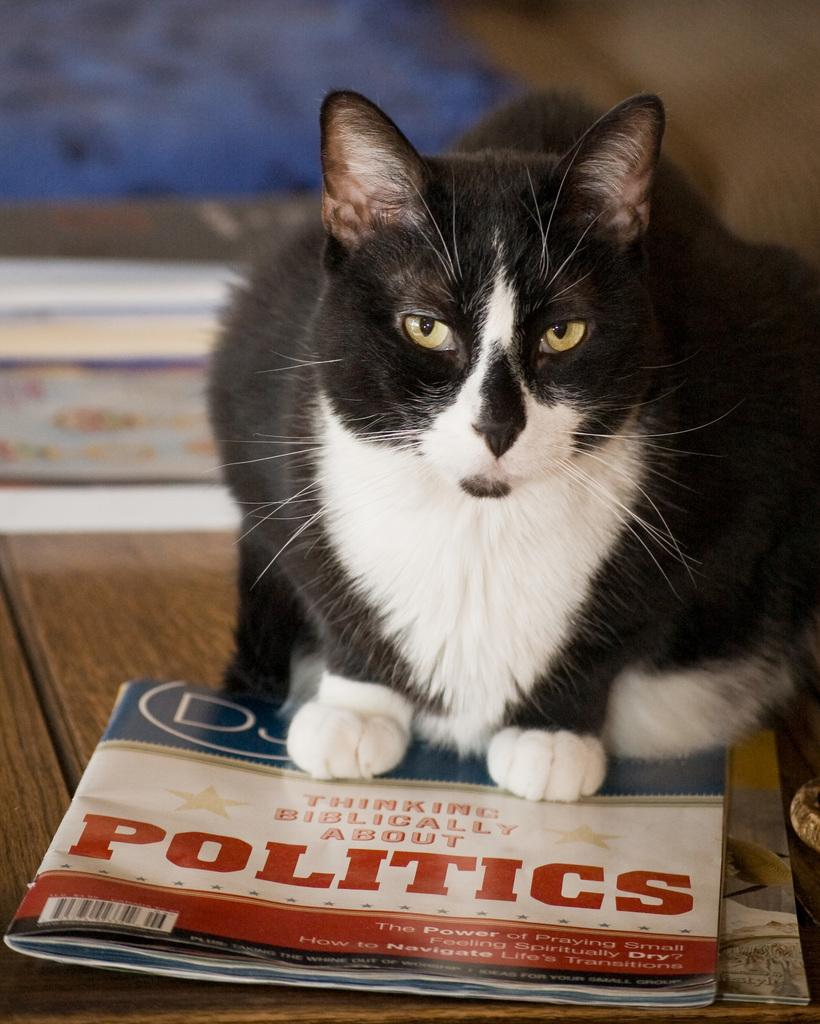<image>
Present a compact description of the photo's key features. A black and white cat sitting on a magazine about politics. 